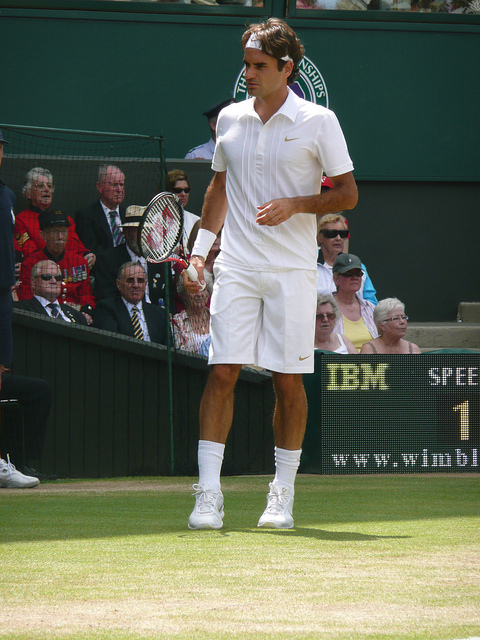Please transcribe the text in this image. IBM SPEE 1 NSHIPS 